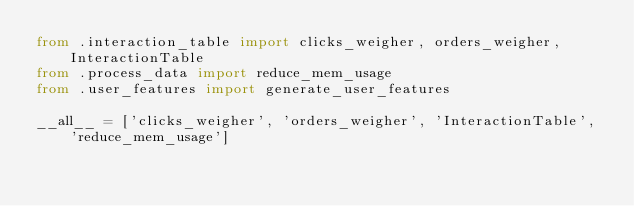<code> <loc_0><loc_0><loc_500><loc_500><_Python_>from .interaction_table import clicks_weigher, orders_weigher, InteractionTable
from .process_data import reduce_mem_usage
from .user_features import generate_user_features

__all__ = ['clicks_weigher', 'orders_weigher', 'InteractionTable', 'reduce_mem_usage']
</code> 